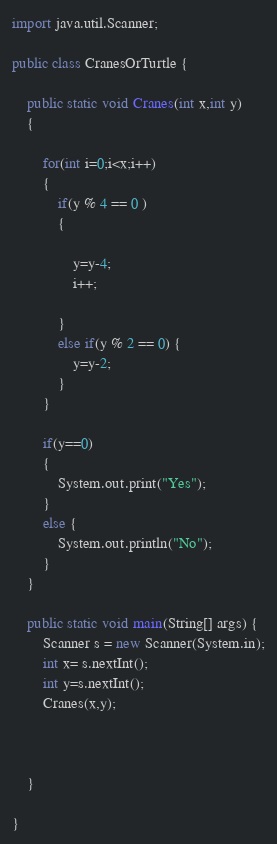<code> <loc_0><loc_0><loc_500><loc_500><_Java_>import java.util.Scanner;

public class CranesOrTurtle {
	
	public static void Cranes(int x,int y)
	{
		
		for(int i=0;i<x;i++)
		{
			if(y % 4 == 0 )
			{
				
				y=y-4;
				i++;
	
			}
			else if(y % 2 == 0) {
				y=y-2;
			}
		}
		
		if(y==0)
		{
			System.out.print("Yes");
		}
		else {
			System.out.println("No");
		}
	}

	public static void main(String[] args) {
		Scanner s = new Scanner(System.in);
		int x= s.nextInt();
		int y=s.nextInt();
		Cranes(x,y);
				
		

	}

}
</code> 